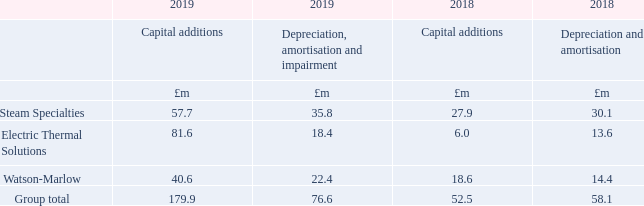3 Segmental reporting continued
Capital additions, depreciation, amortisation and impairment
Capital additions include property, plant and equipment of £59.0m (2018: £33.5m), of which £8.1m (2018: £0.2m) was from acquisitions in the period, and other intangible assets of £72.0m (2018: £19.0m) of which £60.2m (2018: £9.1m) relates to acquired intangibles from acquisitions in the period. Right-of-use asset additions of £48.9m occurred during the 12 month period to 31st December 2019, of which £36.1m relates to additions on 1st January 2019 as a result of transition to IFRS 16, £11.7m relates to new leases entered into in 2019 and £1.1m from acquisitions. Capital additions split between the UK and rest of the world are UK £36.8m (2018: £20.1m) and rest of the world £143.1m (2018: £32.4m).
How were the capital additions in 2019 split? Capital additions split between the uk and rest of the world are uk £36.8m (2018: £20.1m) and rest of the world £143.1m. What does capital additions include? Property, plant and equipment of £59.0m (2018: £33.5m), of which £8.1m (2018: £0.2m) was from acquisitions in the period, and other intangible assets of £72.0m (2018: £19.0m) of which £60.2m (2018: £9.1m) relates to acquired intangibles from acquisitions in the period. What are the businesses considered in the table? Steam specialties, electric thermal solutions, watson-marlow. In which year was the amount of capital additions for Steam Specialties larger? 57.7>27.9
Answer: 2019. What was the amount of capital additions for the UK as a percentage of the group total in 2019?
Answer scale should be: percent. 36.8/(36.8+143.1)
Answer: 20.46. What was the percentage change in capital additions in 2019 from 2018 for Steam Specialties?
Answer scale should be: percent. (57.7-27.9)/27.9
Answer: 106.81. 